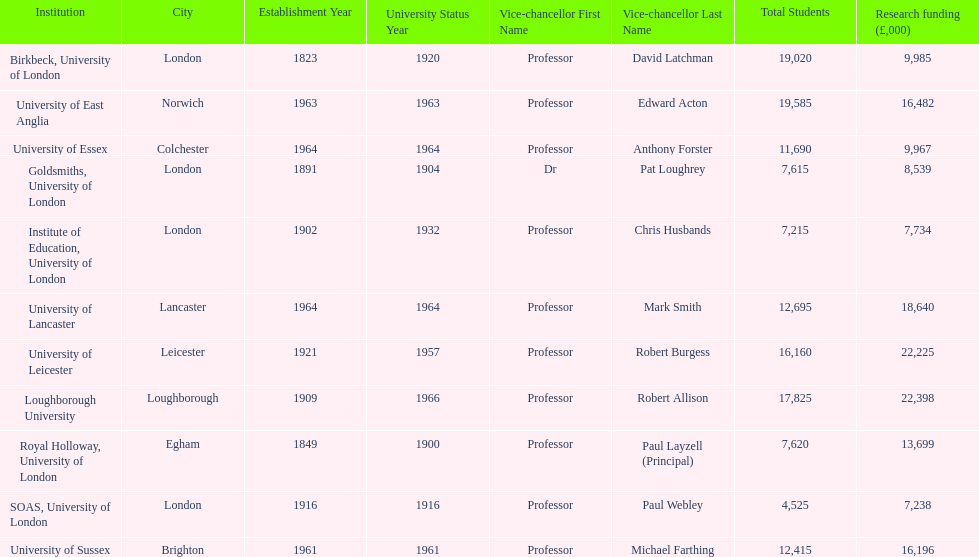What is the most recent institution to gain university status? Loughborough University. 